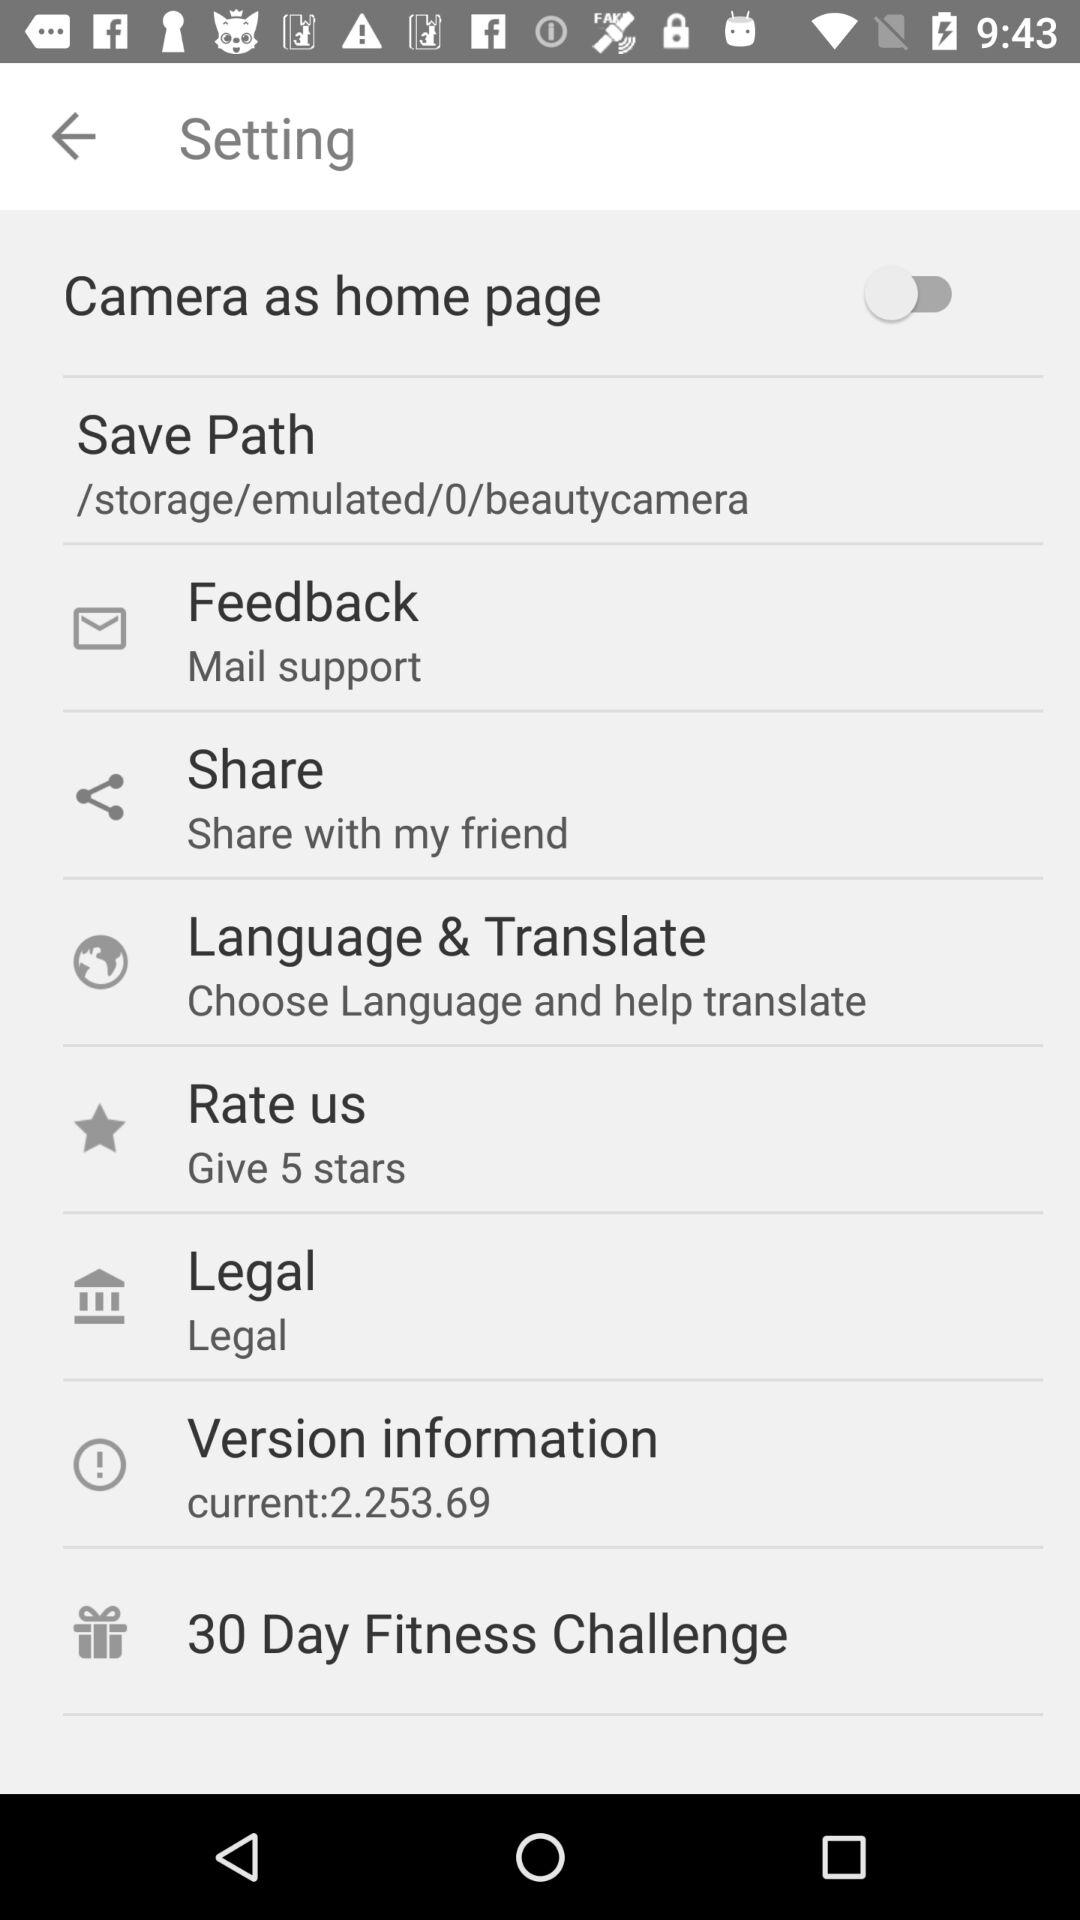What is the current version? The current version is 2.253.69. 